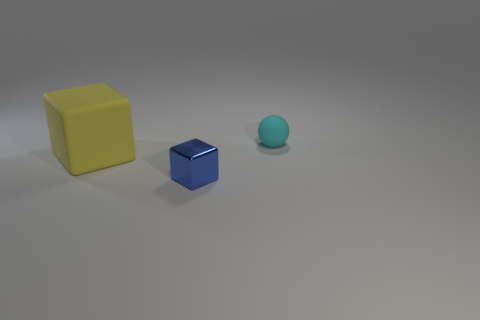Is there any other thing that is the same size as the yellow thing?
Offer a very short reply. No. The yellow cube has what size?
Offer a terse response. Large. How many cyan objects are made of the same material as the big yellow object?
Your response must be concise. 1. Do the yellow matte thing and the cyan matte thing have the same size?
Offer a terse response. No. What shape is the object that is right of the big yellow cube and on the left side of the cyan ball?
Offer a terse response. Cube. What size is the thing on the right side of the metallic thing?
Keep it short and to the point. Small. How many cubes are on the right side of the large yellow block that is on the left side of the small thing in front of the small cyan thing?
Your answer should be compact. 1. There is a tiny cyan thing; are there any things on the left side of it?
Ensure brevity in your answer.  Yes. How many other things are there of the same size as the shiny object?
Your answer should be compact. 1. What is the material of the thing that is behind the blue block and on the right side of the large object?
Ensure brevity in your answer.  Rubber. 